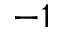Convert formula to latex. <formula><loc_0><loc_0><loc_500><loc_500>- 1</formula> 